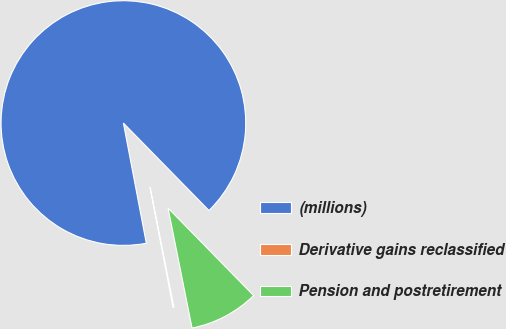Convert chart. <chart><loc_0><loc_0><loc_500><loc_500><pie_chart><fcel>(millions)<fcel>Derivative gains reclassified<fcel>Pension and postretirement<nl><fcel>90.68%<fcel>0.14%<fcel>9.19%<nl></chart> 